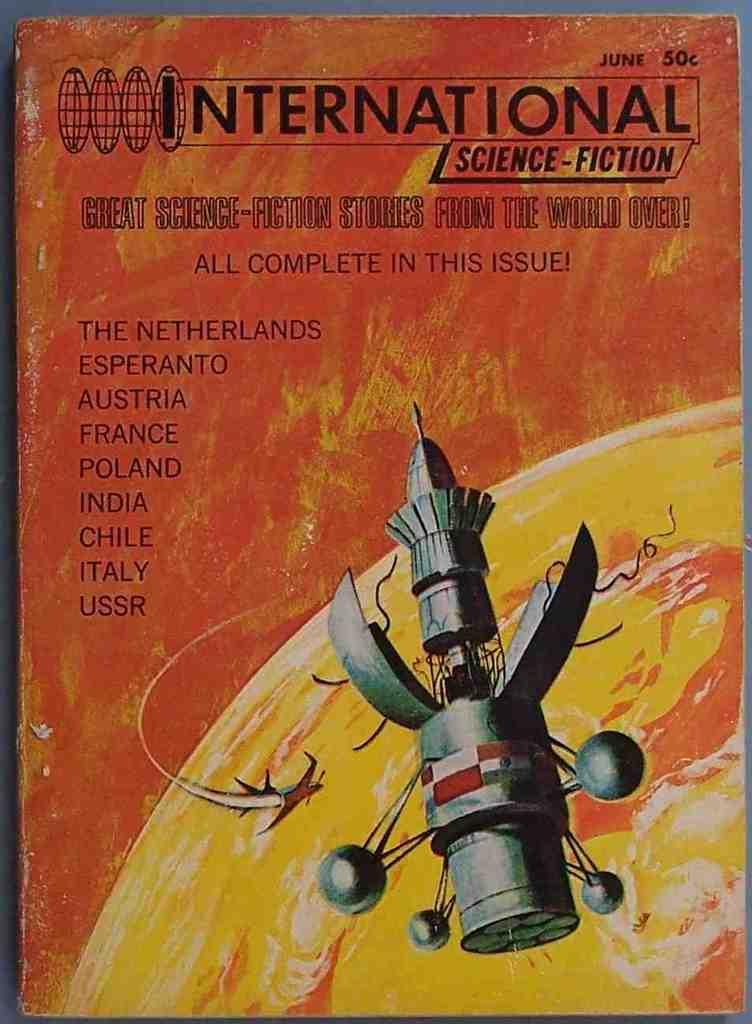<image>
Provide a brief description of the given image. An old looking book which has the words International Science Fiction along the top. 